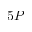<formula> <loc_0><loc_0><loc_500><loc_500>5 P</formula> 